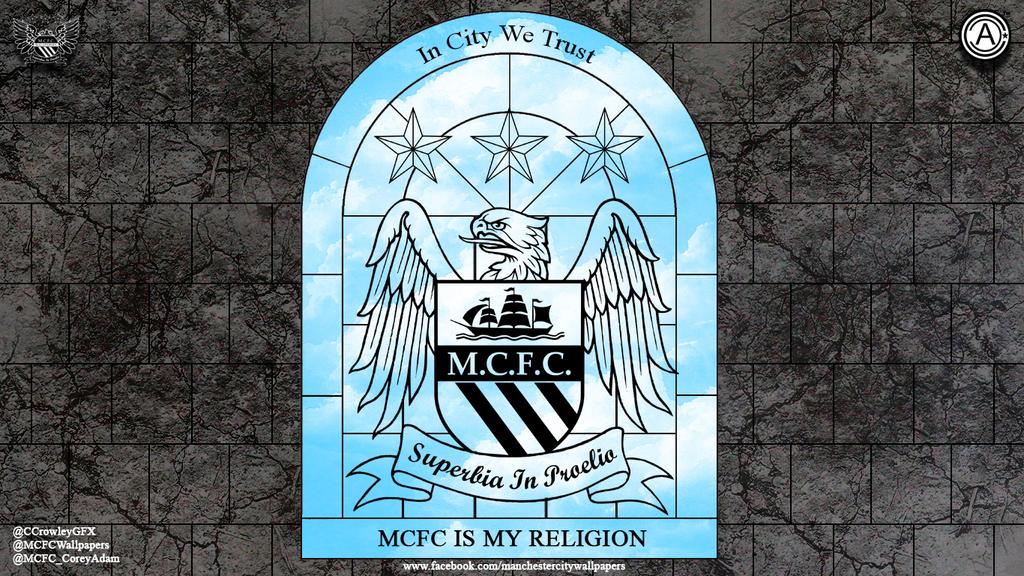What does it say is the religion?
Your response must be concise. Mcfc. 